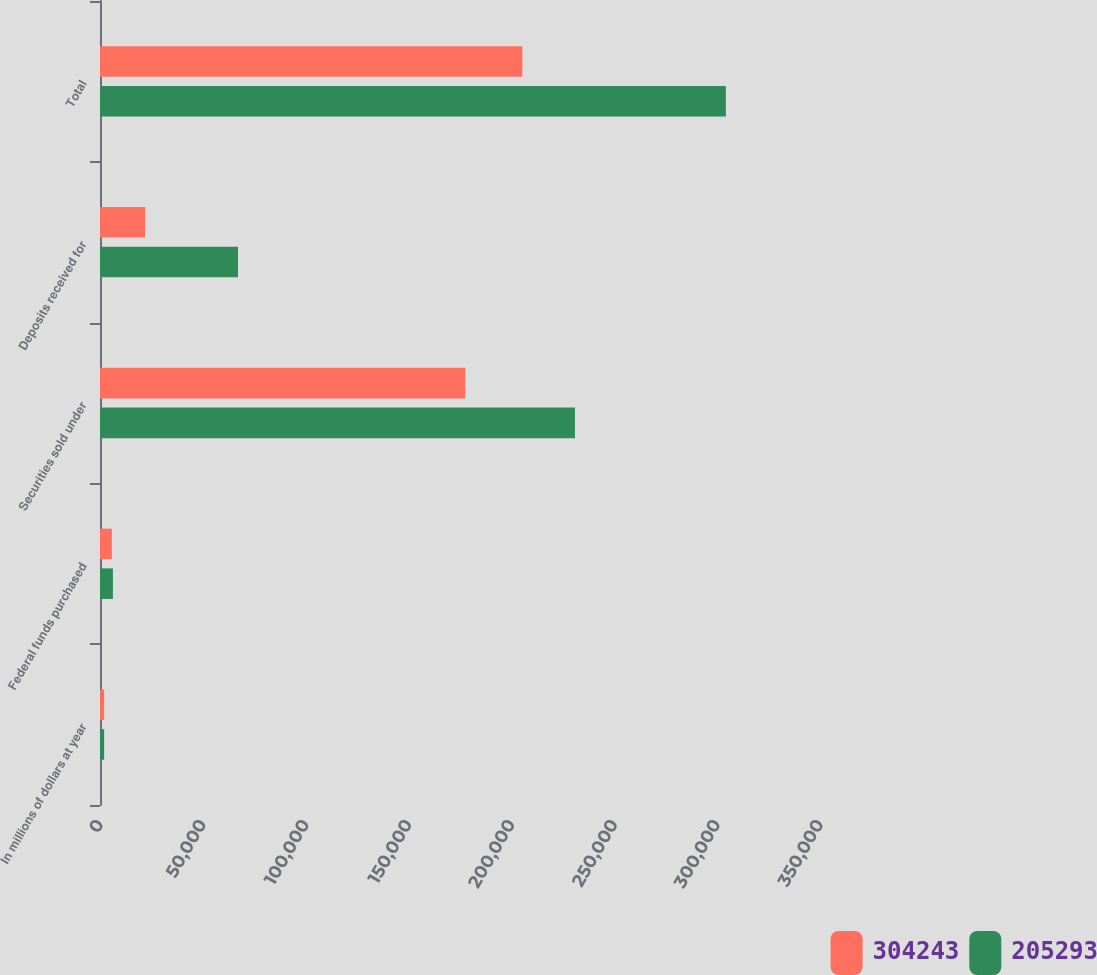<chart> <loc_0><loc_0><loc_500><loc_500><stacked_bar_chart><ecel><fcel>In millions of dollars at year<fcel>Federal funds purchased<fcel>Securities sold under<fcel>Deposits received for<fcel>Total<nl><fcel>304243<fcel>2008<fcel>5755<fcel>177585<fcel>21953<fcel>205293<nl><fcel>205293<fcel>2007<fcel>6279<fcel>230880<fcel>67084<fcel>304243<nl></chart> 